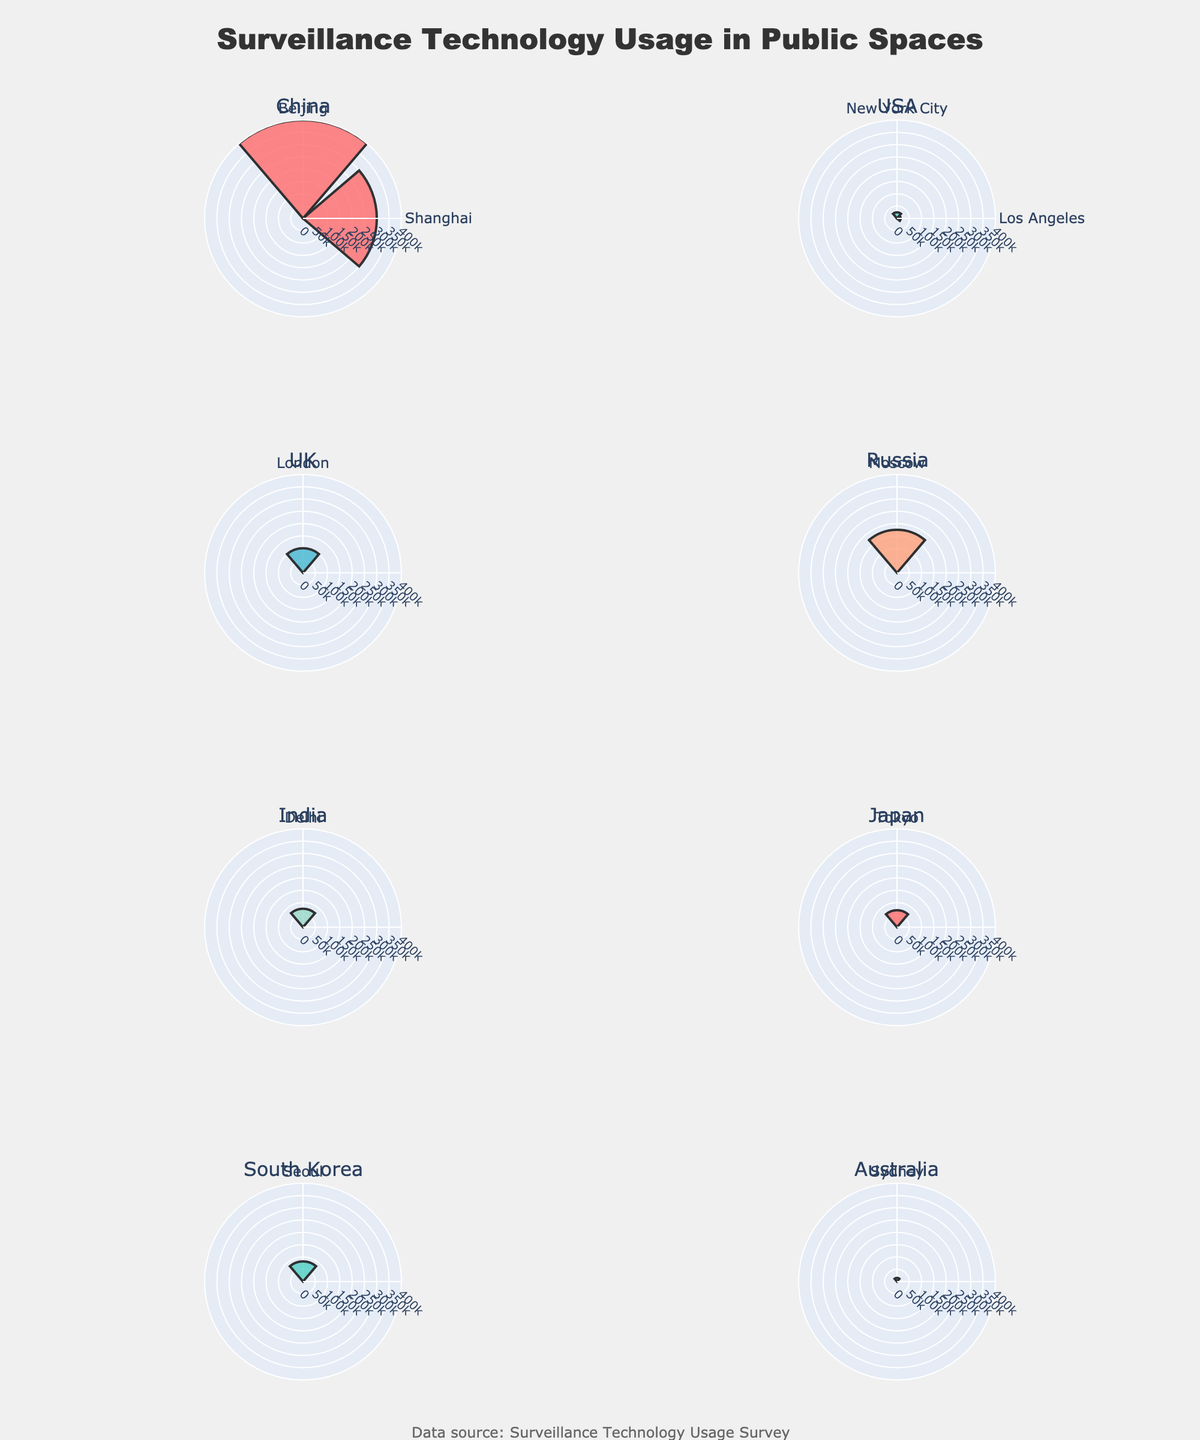Which country has the highest number of surveillance cameras in a single city? The bar length indicates the number of cameras in each city. Beijing, China, shows the longest bar, indicating 400,000 cameras.
Answer: China Which cities in the USA use surveillance technology, and what types are they? The figure shows bars for New York City and Los Angeles under the USA subplot. New York City uses CCTV while Los Angeles uses Traffic Monitoring.
Answer: New York City: CCTV, Los Angeles: Traffic Monitoring What is the public acceptance percentage for facial recognition cameras in Seoul? Check the subplot for South Korea. Seoul's public acceptance percentage for facial recognition cameras is indicated next to the bar.
Answer: 58% How many countries have more than one city represented in the figure? The data shows multiple cities only for China (Beijing, Shanghai) and the USA (New York City, Los Angeles).
Answer: 2 Which country has the largest range of areas covered by surveillance technology when comparing all its cities? Compare the "Area of Coverage (km²)" between cities within each country subplot. China (Beijing: 16410.54 km², Shanghai: 6340.50 km²) shows the largest difference.
Answer: China Which city has the least number of surveillance cameras and how many are there? The shortest bars in all subplots represent Sydney and Los Angeles, indicating 15,000 cameras each.
Answer: Sydney, 15,000 Which city in India is included in the figure and what type of surveillance does it use? Check the India subplot where Delhi is shown using Public Monitoring.
Answer: Delhi, Public Monitoring What's the difference in the number of cameras between Tokyo and Moscow? Tokyo has 69,000 cameras, and Moscow has 175,000 cameras. Calculate the difference: 175,000 - 69,000 = 106,000.
Answer: 106,000 Which country has the highest public acceptance percentage for CCTV usage, and what is the percentage? Check the country subplots with CCTV usage. London, UK has a public acceptance of 75%.
Answer: UK, 75% What type of surveillance technology is most prevalent in Beijing and what is its area of coverage? Beijing's bar indicates Facial Recognition technology covering an area of 16410.54 km².
Answer: Facial Recognition, 16410.54 km² 